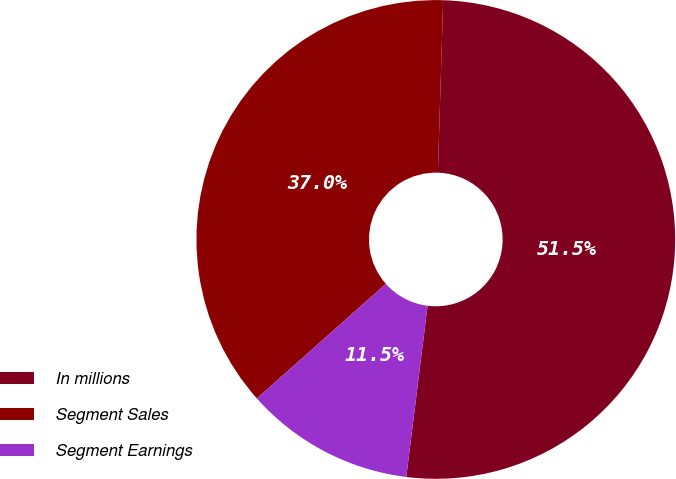<chart> <loc_0><loc_0><loc_500><loc_500><pie_chart><fcel>In millions<fcel>Segment Sales<fcel>Segment Earnings<nl><fcel>51.48%<fcel>37.05%<fcel>11.47%<nl></chart> 